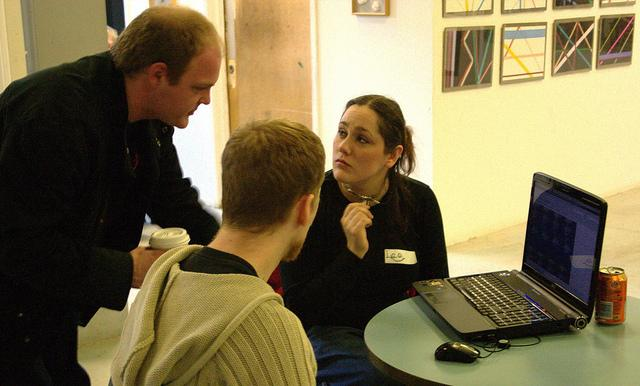What are the people assembled around? Please explain your reasoning. laptop. The computer can be seen on the desk. 